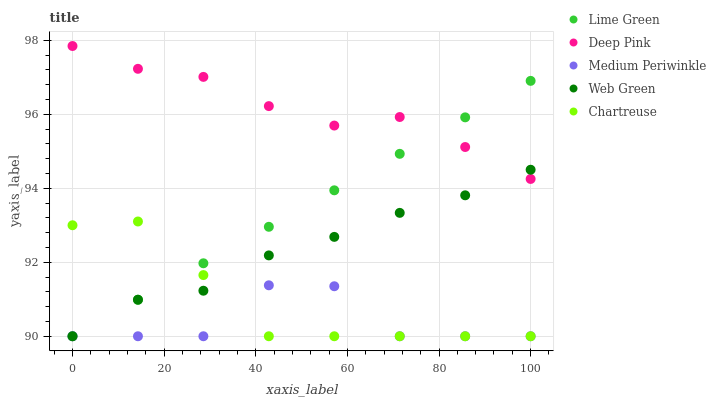Does Medium Periwinkle have the minimum area under the curve?
Answer yes or no. Yes. Does Deep Pink have the maximum area under the curve?
Answer yes or no. Yes. Does Chartreuse have the minimum area under the curve?
Answer yes or no. No. Does Chartreuse have the maximum area under the curve?
Answer yes or no. No. Is Lime Green the smoothest?
Answer yes or no. Yes. Is Medium Periwinkle the roughest?
Answer yes or no. Yes. Is Chartreuse the smoothest?
Answer yes or no. No. Is Chartreuse the roughest?
Answer yes or no. No. Does Medium Periwinkle have the lowest value?
Answer yes or no. Yes. Does Deep Pink have the lowest value?
Answer yes or no. No. Does Deep Pink have the highest value?
Answer yes or no. Yes. Does Chartreuse have the highest value?
Answer yes or no. No. Is Chartreuse less than Deep Pink?
Answer yes or no. Yes. Is Deep Pink greater than Chartreuse?
Answer yes or no. Yes. Does Lime Green intersect Medium Periwinkle?
Answer yes or no. Yes. Is Lime Green less than Medium Periwinkle?
Answer yes or no. No. Is Lime Green greater than Medium Periwinkle?
Answer yes or no. No. Does Chartreuse intersect Deep Pink?
Answer yes or no. No. 